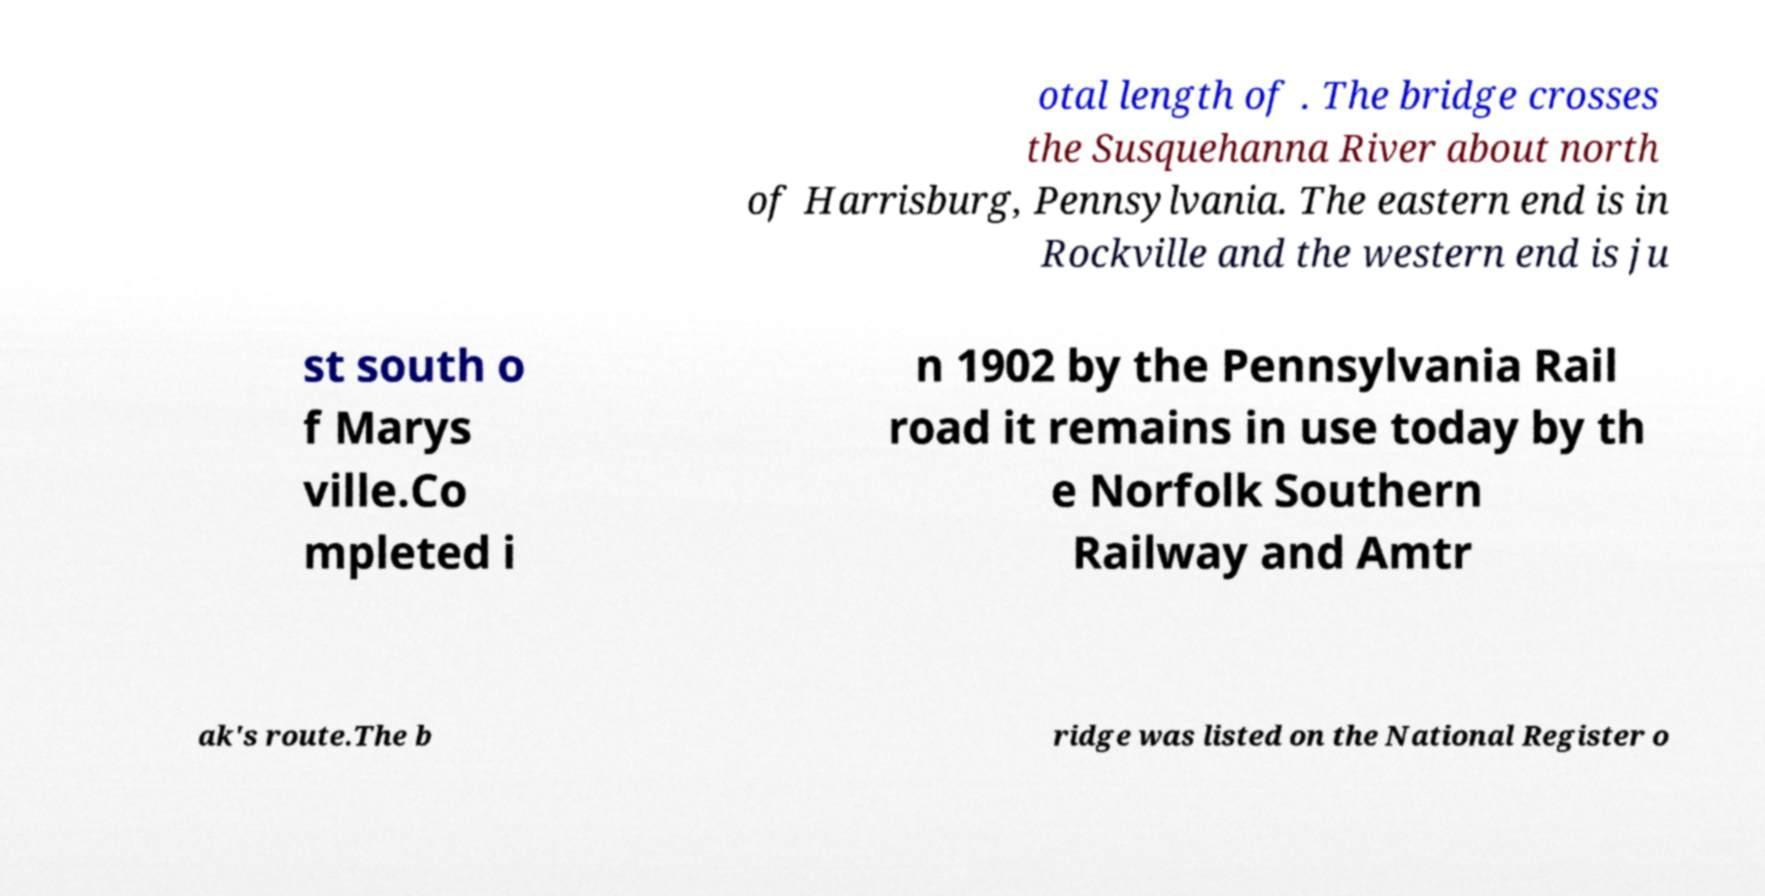Could you assist in decoding the text presented in this image and type it out clearly? otal length of . The bridge crosses the Susquehanna River about north of Harrisburg, Pennsylvania. The eastern end is in Rockville and the western end is ju st south o f Marys ville.Co mpleted i n 1902 by the Pennsylvania Rail road it remains in use today by th e Norfolk Southern Railway and Amtr ak's route.The b ridge was listed on the National Register o 